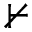<formula> <loc_0><loc_0><loc_500><loc_500>\nvdash</formula> 